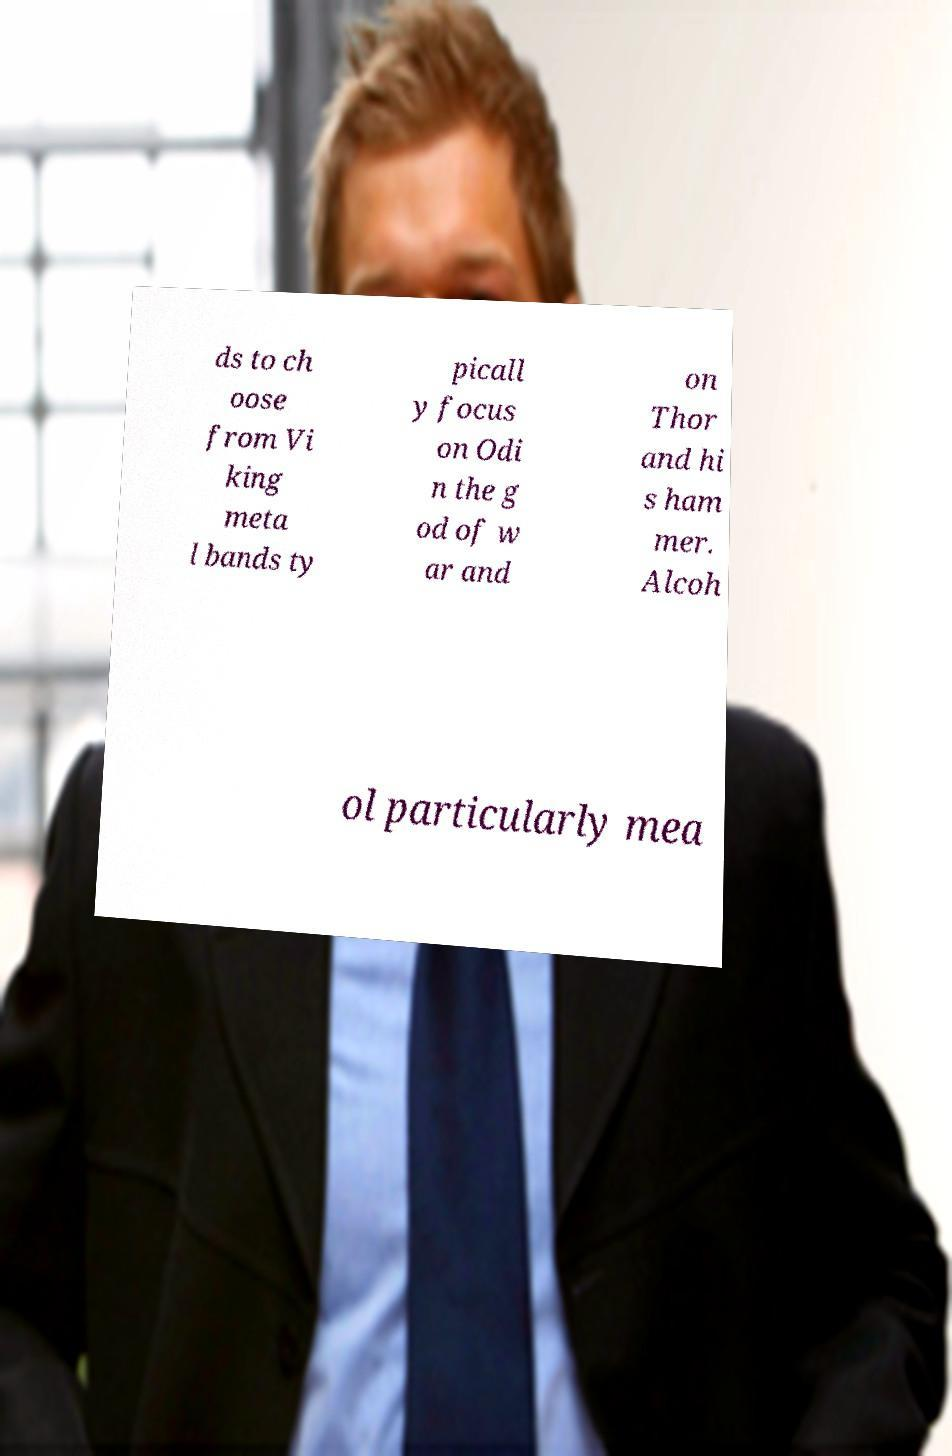Can you read and provide the text displayed in the image?This photo seems to have some interesting text. Can you extract and type it out for me? ds to ch oose from Vi king meta l bands ty picall y focus on Odi n the g od of w ar and on Thor and hi s ham mer. Alcoh ol particularly mea 